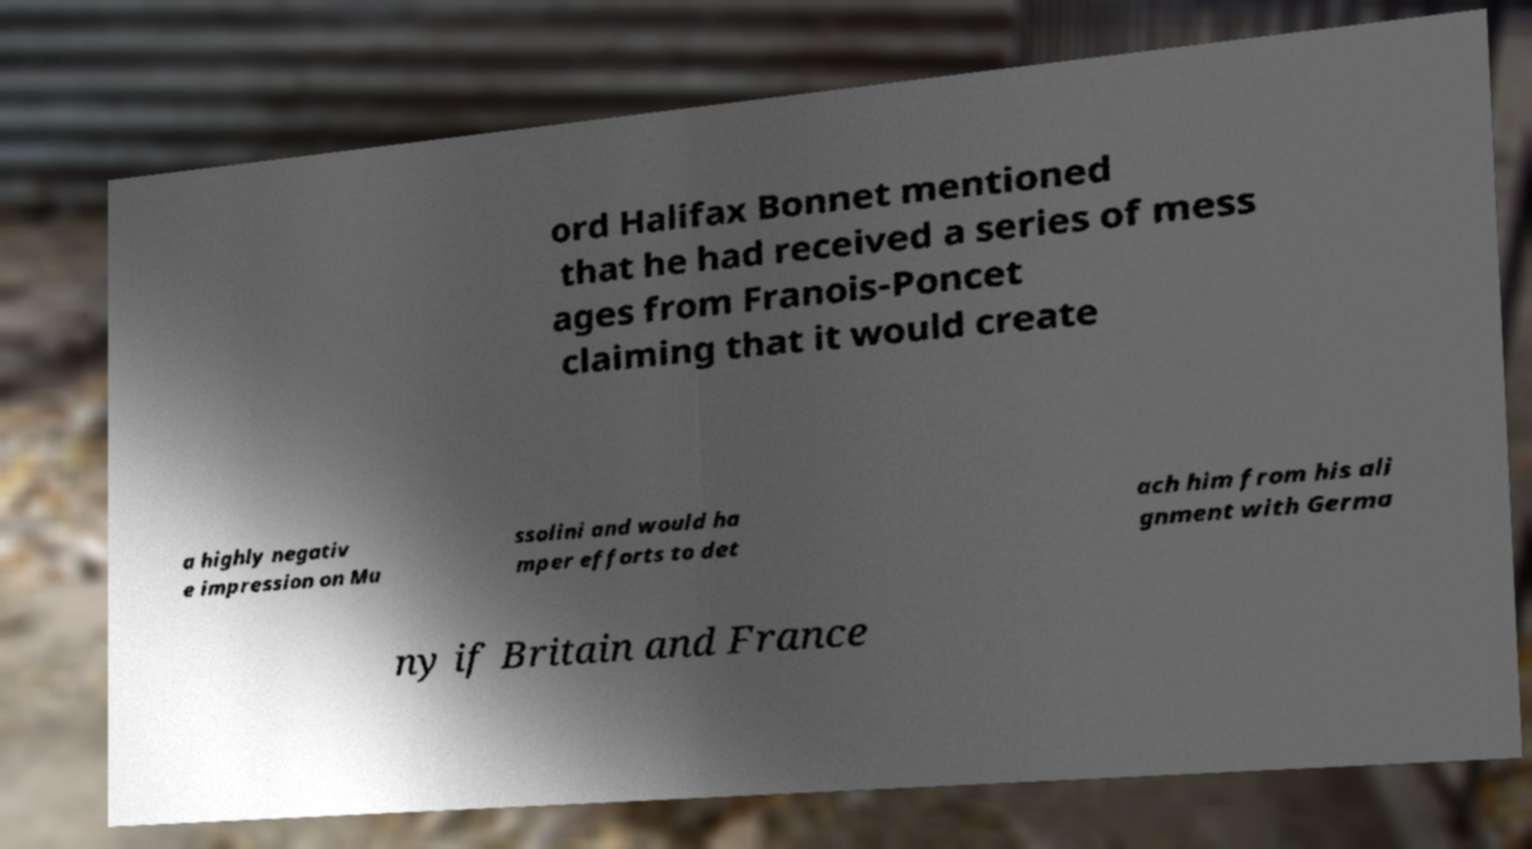What messages or text are displayed in this image? I need them in a readable, typed format. ord Halifax Bonnet mentioned that he had received a series of mess ages from Franois-Poncet claiming that it would create a highly negativ e impression on Mu ssolini and would ha mper efforts to det ach him from his ali gnment with Germa ny if Britain and France 